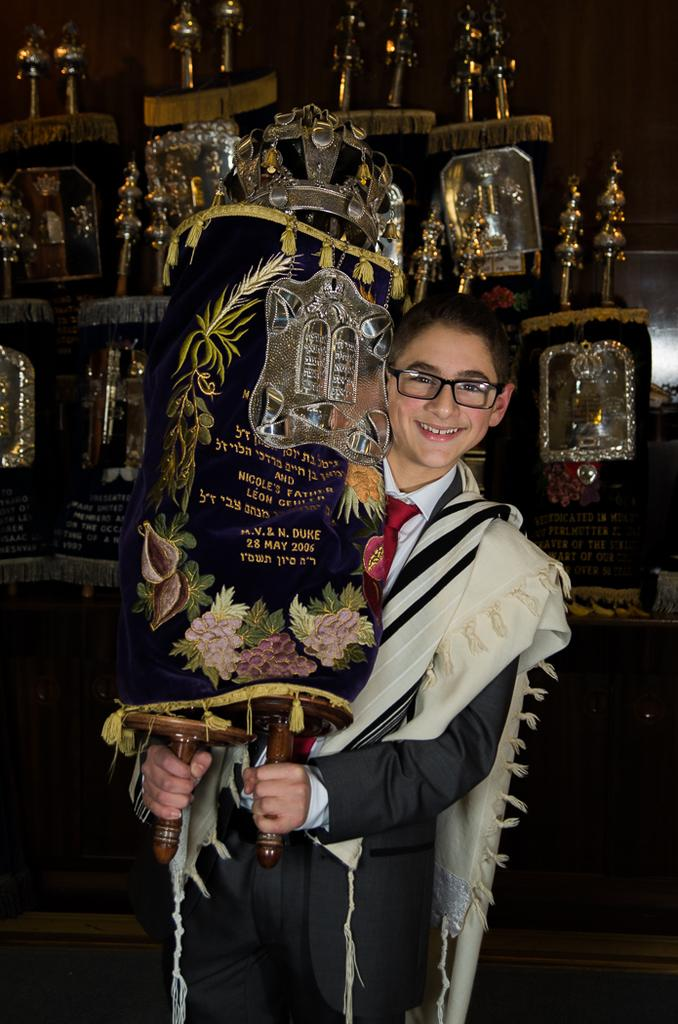What is the main subject of the image? There is a boy in the center of the image. What is the boy holding in his hands? The boy is holding a trophy in his hands. Can you describe the background of the image? There are other trophies visible in the background of the image. What type of milk is the boy drinking in the image? There is no milk present in the image; the boy is holding a trophy. 